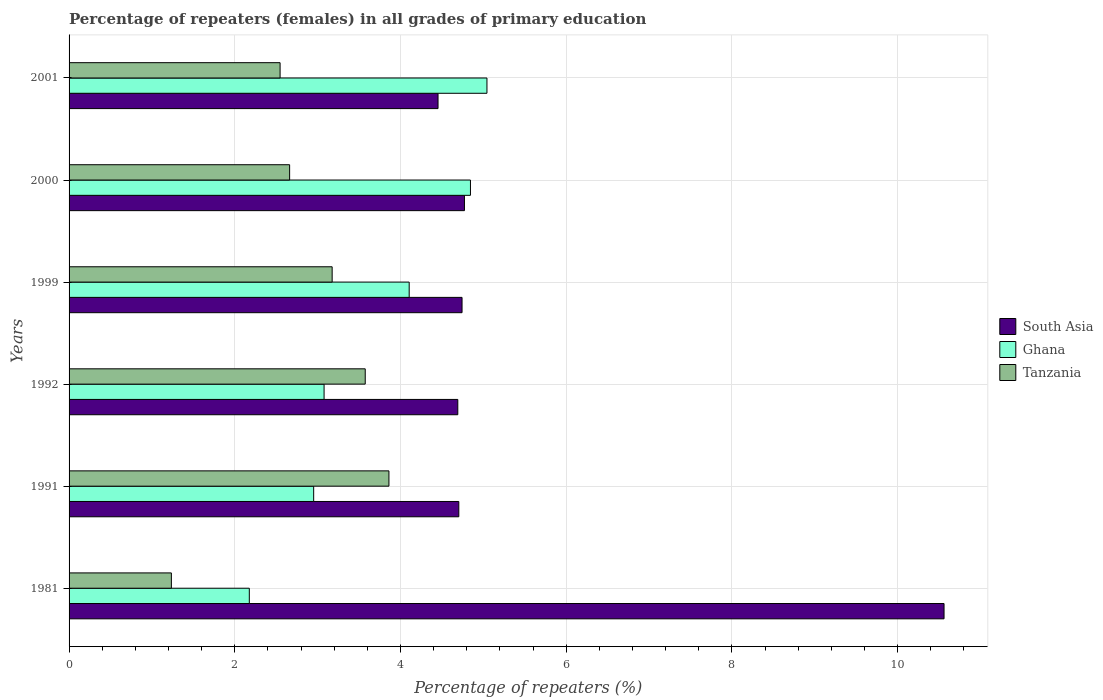Are the number of bars per tick equal to the number of legend labels?
Make the answer very short. Yes. How many bars are there on the 3rd tick from the top?
Your answer should be compact. 3. How many bars are there on the 1st tick from the bottom?
Make the answer very short. 3. What is the label of the 6th group of bars from the top?
Make the answer very short. 1981. In how many cases, is the number of bars for a given year not equal to the number of legend labels?
Offer a terse response. 0. What is the percentage of repeaters (females) in South Asia in 2000?
Give a very brief answer. 4.77. Across all years, what is the maximum percentage of repeaters (females) in Ghana?
Provide a short and direct response. 5.04. Across all years, what is the minimum percentage of repeaters (females) in Tanzania?
Your answer should be compact. 1.23. In which year was the percentage of repeaters (females) in South Asia maximum?
Offer a terse response. 1981. In which year was the percentage of repeaters (females) in South Asia minimum?
Provide a succinct answer. 2001. What is the total percentage of repeaters (females) in Tanzania in the graph?
Make the answer very short. 17.05. What is the difference between the percentage of repeaters (females) in South Asia in 1999 and that in 2001?
Your answer should be very brief. 0.29. What is the difference between the percentage of repeaters (females) in Tanzania in 1991 and the percentage of repeaters (females) in Ghana in 1999?
Offer a terse response. -0.24. What is the average percentage of repeaters (females) in South Asia per year?
Your answer should be very brief. 5.65. In the year 2001, what is the difference between the percentage of repeaters (females) in South Asia and percentage of repeaters (females) in Tanzania?
Offer a very short reply. 1.91. What is the ratio of the percentage of repeaters (females) in Tanzania in 1981 to that in 2000?
Provide a succinct answer. 0.46. Is the percentage of repeaters (females) in Ghana in 2000 less than that in 2001?
Your answer should be very brief. Yes. Is the difference between the percentage of repeaters (females) in South Asia in 2000 and 2001 greater than the difference between the percentage of repeaters (females) in Tanzania in 2000 and 2001?
Your answer should be very brief. Yes. What is the difference between the highest and the second highest percentage of repeaters (females) in South Asia?
Make the answer very short. 5.79. What is the difference between the highest and the lowest percentage of repeaters (females) in South Asia?
Your answer should be compact. 6.11. Is the sum of the percentage of repeaters (females) in Ghana in 1992 and 2001 greater than the maximum percentage of repeaters (females) in South Asia across all years?
Your response must be concise. No. What does the 2nd bar from the bottom in 1991 represents?
Ensure brevity in your answer.  Ghana. Is it the case that in every year, the sum of the percentage of repeaters (females) in South Asia and percentage of repeaters (females) in Ghana is greater than the percentage of repeaters (females) in Tanzania?
Ensure brevity in your answer.  Yes. How many bars are there?
Provide a succinct answer. 18. Are all the bars in the graph horizontal?
Your answer should be very brief. Yes. Does the graph contain any zero values?
Offer a terse response. No. Does the graph contain grids?
Provide a short and direct response. Yes. Where does the legend appear in the graph?
Offer a very short reply. Center right. What is the title of the graph?
Your answer should be very brief. Percentage of repeaters (females) in all grades of primary education. What is the label or title of the X-axis?
Offer a very short reply. Percentage of repeaters (%). What is the label or title of the Y-axis?
Provide a short and direct response. Years. What is the Percentage of repeaters (%) of South Asia in 1981?
Make the answer very short. 10.56. What is the Percentage of repeaters (%) in Ghana in 1981?
Ensure brevity in your answer.  2.18. What is the Percentage of repeaters (%) of Tanzania in 1981?
Your response must be concise. 1.23. What is the Percentage of repeaters (%) of South Asia in 1991?
Give a very brief answer. 4.7. What is the Percentage of repeaters (%) in Ghana in 1991?
Your answer should be very brief. 2.95. What is the Percentage of repeaters (%) of Tanzania in 1991?
Provide a succinct answer. 3.86. What is the Percentage of repeaters (%) in South Asia in 1992?
Make the answer very short. 4.69. What is the Percentage of repeaters (%) in Ghana in 1992?
Keep it short and to the point. 3.08. What is the Percentage of repeaters (%) in Tanzania in 1992?
Offer a terse response. 3.57. What is the Percentage of repeaters (%) of South Asia in 1999?
Your response must be concise. 4.74. What is the Percentage of repeaters (%) of Ghana in 1999?
Your response must be concise. 4.11. What is the Percentage of repeaters (%) of Tanzania in 1999?
Provide a short and direct response. 3.18. What is the Percentage of repeaters (%) in South Asia in 2000?
Give a very brief answer. 4.77. What is the Percentage of repeaters (%) of Ghana in 2000?
Make the answer very short. 4.84. What is the Percentage of repeaters (%) in Tanzania in 2000?
Offer a terse response. 2.66. What is the Percentage of repeaters (%) of South Asia in 2001?
Provide a short and direct response. 4.45. What is the Percentage of repeaters (%) of Ghana in 2001?
Offer a very short reply. 5.04. What is the Percentage of repeaters (%) of Tanzania in 2001?
Your response must be concise. 2.55. Across all years, what is the maximum Percentage of repeaters (%) of South Asia?
Make the answer very short. 10.56. Across all years, what is the maximum Percentage of repeaters (%) in Ghana?
Your answer should be very brief. 5.04. Across all years, what is the maximum Percentage of repeaters (%) of Tanzania?
Keep it short and to the point. 3.86. Across all years, what is the minimum Percentage of repeaters (%) in South Asia?
Keep it short and to the point. 4.45. Across all years, what is the minimum Percentage of repeaters (%) in Ghana?
Your answer should be very brief. 2.18. Across all years, what is the minimum Percentage of repeaters (%) in Tanzania?
Offer a terse response. 1.23. What is the total Percentage of repeaters (%) of South Asia in the graph?
Offer a very short reply. 33.93. What is the total Percentage of repeaters (%) of Ghana in the graph?
Provide a short and direct response. 22.2. What is the total Percentage of repeaters (%) of Tanzania in the graph?
Offer a terse response. 17.05. What is the difference between the Percentage of repeaters (%) in South Asia in 1981 and that in 1991?
Keep it short and to the point. 5.86. What is the difference between the Percentage of repeaters (%) of Ghana in 1981 and that in 1991?
Provide a succinct answer. -0.78. What is the difference between the Percentage of repeaters (%) in Tanzania in 1981 and that in 1991?
Your answer should be compact. -2.63. What is the difference between the Percentage of repeaters (%) of South Asia in 1981 and that in 1992?
Your answer should be compact. 5.87. What is the difference between the Percentage of repeaters (%) of Ghana in 1981 and that in 1992?
Offer a terse response. -0.9. What is the difference between the Percentage of repeaters (%) in Tanzania in 1981 and that in 1992?
Your response must be concise. -2.34. What is the difference between the Percentage of repeaters (%) of South Asia in 1981 and that in 1999?
Offer a very short reply. 5.82. What is the difference between the Percentage of repeaters (%) of Ghana in 1981 and that in 1999?
Your answer should be very brief. -1.93. What is the difference between the Percentage of repeaters (%) in Tanzania in 1981 and that in 1999?
Provide a short and direct response. -1.94. What is the difference between the Percentage of repeaters (%) in South Asia in 1981 and that in 2000?
Provide a succinct answer. 5.79. What is the difference between the Percentage of repeaters (%) of Ghana in 1981 and that in 2000?
Provide a succinct answer. -2.67. What is the difference between the Percentage of repeaters (%) in Tanzania in 1981 and that in 2000?
Offer a terse response. -1.43. What is the difference between the Percentage of repeaters (%) in South Asia in 1981 and that in 2001?
Give a very brief answer. 6.11. What is the difference between the Percentage of repeaters (%) in Ghana in 1981 and that in 2001?
Your response must be concise. -2.87. What is the difference between the Percentage of repeaters (%) in Tanzania in 1981 and that in 2001?
Your answer should be very brief. -1.31. What is the difference between the Percentage of repeaters (%) in South Asia in 1991 and that in 1992?
Your answer should be very brief. 0.01. What is the difference between the Percentage of repeaters (%) in Ghana in 1991 and that in 1992?
Your answer should be very brief. -0.13. What is the difference between the Percentage of repeaters (%) in Tanzania in 1991 and that in 1992?
Ensure brevity in your answer.  0.29. What is the difference between the Percentage of repeaters (%) of South Asia in 1991 and that in 1999?
Ensure brevity in your answer.  -0.04. What is the difference between the Percentage of repeaters (%) of Ghana in 1991 and that in 1999?
Your answer should be compact. -1.15. What is the difference between the Percentage of repeaters (%) in Tanzania in 1991 and that in 1999?
Offer a very short reply. 0.69. What is the difference between the Percentage of repeaters (%) of South Asia in 1991 and that in 2000?
Offer a terse response. -0.07. What is the difference between the Percentage of repeaters (%) in Ghana in 1991 and that in 2000?
Offer a very short reply. -1.89. What is the difference between the Percentage of repeaters (%) in Tanzania in 1991 and that in 2000?
Your answer should be compact. 1.2. What is the difference between the Percentage of repeaters (%) in South Asia in 1991 and that in 2001?
Offer a very short reply. 0.25. What is the difference between the Percentage of repeaters (%) of Ghana in 1991 and that in 2001?
Provide a succinct answer. -2.09. What is the difference between the Percentage of repeaters (%) of Tanzania in 1991 and that in 2001?
Provide a succinct answer. 1.31. What is the difference between the Percentage of repeaters (%) in South Asia in 1992 and that in 1999?
Ensure brevity in your answer.  -0.05. What is the difference between the Percentage of repeaters (%) in Ghana in 1992 and that in 1999?
Your answer should be compact. -1.03. What is the difference between the Percentage of repeaters (%) of Tanzania in 1992 and that in 1999?
Make the answer very short. 0.4. What is the difference between the Percentage of repeaters (%) of South Asia in 1992 and that in 2000?
Make the answer very short. -0.08. What is the difference between the Percentage of repeaters (%) of Ghana in 1992 and that in 2000?
Provide a succinct answer. -1.77. What is the difference between the Percentage of repeaters (%) in Tanzania in 1992 and that in 2000?
Provide a succinct answer. 0.91. What is the difference between the Percentage of repeaters (%) of South Asia in 1992 and that in 2001?
Offer a very short reply. 0.24. What is the difference between the Percentage of repeaters (%) in Ghana in 1992 and that in 2001?
Offer a terse response. -1.97. What is the difference between the Percentage of repeaters (%) of Tanzania in 1992 and that in 2001?
Your answer should be compact. 1.03. What is the difference between the Percentage of repeaters (%) of South Asia in 1999 and that in 2000?
Offer a very short reply. -0.03. What is the difference between the Percentage of repeaters (%) in Ghana in 1999 and that in 2000?
Make the answer very short. -0.74. What is the difference between the Percentage of repeaters (%) in Tanzania in 1999 and that in 2000?
Ensure brevity in your answer.  0.51. What is the difference between the Percentage of repeaters (%) in South Asia in 1999 and that in 2001?
Provide a short and direct response. 0.29. What is the difference between the Percentage of repeaters (%) of Ghana in 1999 and that in 2001?
Make the answer very short. -0.94. What is the difference between the Percentage of repeaters (%) of Tanzania in 1999 and that in 2001?
Give a very brief answer. 0.63. What is the difference between the Percentage of repeaters (%) in South Asia in 2000 and that in 2001?
Make the answer very short. 0.32. What is the difference between the Percentage of repeaters (%) of Ghana in 2000 and that in 2001?
Offer a terse response. -0.2. What is the difference between the Percentage of repeaters (%) in Tanzania in 2000 and that in 2001?
Offer a terse response. 0.12. What is the difference between the Percentage of repeaters (%) of South Asia in 1981 and the Percentage of repeaters (%) of Ghana in 1991?
Provide a short and direct response. 7.61. What is the difference between the Percentage of repeaters (%) in Ghana in 1981 and the Percentage of repeaters (%) in Tanzania in 1991?
Give a very brief answer. -1.69. What is the difference between the Percentage of repeaters (%) in South Asia in 1981 and the Percentage of repeaters (%) in Ghana in 1992?
Your answer should be very brief. 7.48. What is the difference between the Percentage of repeaters (%) of South Asia in 1981 and the Percentage of repeaters (%) of Tanzania in 1992?
Offer a terse response. 6.99. What is the difference between the Percentage of repeaters (%) in Ghana in 1981 and the Percentage of repeaters (%) in Tanzania in 1992?
Your response must be concise. -1.4. What is the difference between the Percentage of repeaters (%) in South Asia in 1981 and the Percentage of repeaters (%) in Ghana in 1999?
Ensure brevity in your answer.  6.46. What is the difference between the Percentage of repeaters (%) of South Asia in 1981 and the Percentage of repeaters (%) of Tanzania in 1999?
Ensure brevity in your answer.  7.39. What is the difference between the Percentage of repeaters (%) in Ghana in 1981 and the Percentage of repeaters (%) in Tanzania in 1999?
Provide a succinct answer. -1. What is the difference between the Percentage of repeaters (%) of South Asia in 1981 and the Percentage of repeaters (%) of Ghana in 2000?
Ensure brevity in your answer.  5.72. What is the difference between the Percentage of repeaters (%) of South Asia in 1981 and the Percentage of repeaters (%) of Tanzania in 2000?
Your answer should be very brief. 7.9. What is the difference between the Percentage of repeaters (%) of Ghana in 1981 and the Percentage of repeaters (%) of Tanzania in 2000?
Provide a short and direct response. -0.49. What is the difference between the Percentage of repeaters (%) in South Asia in 1981 and the Percentage of repeaters (%) in Ghana in 2001?
Ensure brevity in your answer.  5.52. What is the difference between the Percentage of repeaters (%) in South Asia in 1981 and the Percentage of repeaters (%) in Tanzania in 2001?
Your response must be concise. 8.01. What is the difference between the Percentage of repeaters (%) in Ghana in 1981 and the Percentage of repeaters (%) in Tanzania in 2001?
Provide a short and direct response. -0.37. What is the difference between the Percentage of repeaters (%) in South Asia in 1991 and the Percentage of repeaters (%) in Ghana in 1992?
Offer a terse response. 1.63. What is the difference between the Percentage of repeaters (%) in South Asia in 1991 and the Percentage of repeaters (%) in Tanzania in 1992?
Provide a succinct answer. 1.13. What is the difference between the Percentage of repeaters (%) of Ghana in 1991 and the Percentage of repeaters (%) of Tanzania in 1992?
Offer a terse response. -0.62. What is the difference between the Percentage of repeaters (%) of South Asia in 1991 and the Percentage of repeaters (%) of Ghana in 1999?
Keep it short and to the point. 0.6. What is the difference between the Percentage of repeaters (%) of South Asia in 1991 and the Percentage of repeaters (%) of Tanzania in 1999?
Your answer should be compact. 1.53. What is the difference between the Percentage of repeaters (%) of Ghana in 1991 and the Percentage of repeaters (%) of Tanzania in 1999?
Provide a short and direct response. -0.22. What is the difference between the Percentage of repeaters (%) in South Asia in 1991 and the Percentage of repeaters (%) in Ghana in 2000?
Ensure brevity in your answer.  -0.14. What is the difference between the Percentage of repeaters (%) in South Asia in 1991 and the Percentage of repeaters (%) in Tanzania in 2000?
Provide a short and direct response. 2.04. What is the difference between the Percentage of repeaters (%) in Ghana in 1991 and the Percentage of repeaters (%) in Tanzania in 2000?
Offer a terse response. 0.29. What is the difference between the Percentage of repeaters (%) in South Asia in 1991 and the Percentage of repeaters (%) in Ghana in 2001?
Your response must be concise. -0.34. What is the difference between the Percentage of repeaters (%) of South Asia in 1991 and the Percentage of repeaters (%) of Tanzania in 2001?
Your answer should be very brief. 2.16. What is the difference between the Percentage of repeaters (%) in Ghana in 1991 and the Percentage of repeaters (%) in Tanzania in 2001?
Provide a succinct answer. 0.41. What is the difference between the Percentage of repeaters (%) of South Asia in 1992 and the Percentage of repeaters (%) of Ghana in 1999?
Give a very brief answer. 0.59. What is the difference between the Percentage of repeaters (%) of South Asia in 1992 and the Percentage of repeaters (%) of Tanzania in 1999?
Ensure brevity in your answer.  1.52. What is the difference between the Percentage of repeaters (%) in Ghana in 1992 and the Percentage of repeaters (%) in Tanzania in 1999?
Give a very brief answer. -0.1. What is the difference between the Percentage of repeaters (%) in South Asia in 1992 and the Percentage of repeaters (%) in Ghana in 2000?
Ensure brevity in your answer.  -0.15. What is the difference between the Percentage of repeaters (%) in South Asia in 1992 and the Percentage of repeaters (%) in Tanzania in 2000?
Provide a short and direct response. 2.03. What is the difference between the Percentage of repeaters (%) of Ghana in 1992 and the Percentage of repeaters (%) of Tanzania in 2000?
Offer a very short reply. 0.42. What is the difference between the Percentage of repeaters (%) of South Asia in 1992 and the Percentage of repeaters (%) of Ghana in 2001?
Your answer should be very brief. -0.35. What is the difference between the Percentage of repeaters (%) in South Asia in 1992 and the Percentage of repeaters (%) in Tanzania in 2001?
Offer a very short reply. 2.14. What is the difference between the Percentage of repeaters (%) of Ghana in 1992 and the Percentage of repeaters (%) of Tanzania in 2001?
Keep it short and to the point. 0.53. What is the difference between the Percentage of repeaters (%) in South Asia in 1999 and the Percentage of repeaters (%) in Ghana in 2000?
Your answer should be very brief. -0.1. What is the difference between the Percentage of repeaters (%) in South Asia in 1999 and the Percentage of repeaters (%) in Tanzania in 2000?
Make the answer very short. 2.08. What is the difference between the Percentage of repeaters (%) in Ghana in 1999 and the Percentage of repeaters (%) in Tanzania in 2000?
Ensure brevity in your answer.  1.44. What is the difference between the Percentage of repeaters (%) of South Asia in 1999 and the Percentage of repeaters (%) of Ghana in 2001?
Keep it short and to the point. -0.3. What is the difference between the Percentage of repeaters (%) in South Asia in 1999 and the Percentage of repeaters (%) in Tanzania in 2001?
Your answer should be compact. 2.2. What is the difference between the Percentage of repeaters (%) in Ghana in 1999 and the Percentage of repeaters (%) in Tanzania in 2001?
Your response must be concise. 1.56. What is the difference between the Percentage of repeaters (%) of South Asia in 2000 and the Percentage of repeaters (%) of Ghana in 2001?
Keep it short and to the point. -0.27. What is the difference between the Percentage of repeaters (%) of South Asia in 2000 and the Percentage of repeaters (%) of Tanzania in 2001?
Ensure brevity in your answer.  2.23. What is the difference between the Percentage of repeaters (%) in Ghana in 2000 and the Percentage of repeaters (%) in Tanzania in 2001?
Provide a short and direct response. 2.3. What is the average Percentage of repeaters (%) in South Asia per year?
Ensure brevity in your answer.  5.65. What is the average Percentage of repeaters (%) in Ghana per year?
Make the answer very short. 3.7. What is the average Percentage of repeaters (%) in Tanzania per year?
Keep it short and to the point. 2.84. In the year 1981, what is the difference between the Percentage of repeaters (%) in South Asia and Percentage of repeaters (%) in Ghana?
Make the answer very short. 8.39. In the year 1981, what is the difference between the Percentage of repeaters (%) of South Asia and Percentage of repeaters (%) of Tanzania?
Provide a short and direct response. 9.33. In the year 1981, what is the difference between the Percentage of repeaters (%) of Ghana and Percentage of repeaters (%) of Tanzania?
Ensure brevity in your answer.  0.94. In the year 1991, what is the difference between the Percentage of repeaters (%) of South Asia and Percentage of repeaters (%) of Ghana?
Give a very brief answer. 1.75. In the year 1991, what is the difference between the Percentage of repeaters (%) of South Asia and Percentage of repeaters (%) of Tanzania?
Provide a short and direct response. 0.84. In the year 1991, what is the difference between the Percentage of repeaters (%) of Ghana and Percentage of repeaters (%) of Tanzania?
Your answer should be very brief. -0.91. In the year 1992, what is the difference between the Percentage of repeaters (%) in South Asia and Percentage of repeaters (%) in Ghana?
Keep it short and to the point. 1.61. In the year 1992, what is the difference between the Percentage of repeaters (%) of South Asia and Percentage of repeaters (%) of Tanzania?
Provide a succinct answer. 1.12. In the year 1992, what is the difference between the Percentage of repeaters (%) of Ghana and Percentage of repeaters (%) of Tanzania?
Your response must be concise. -0.5. In the year 1999, what is the difference between the Percentage of repeaters (%) in South Asia and Percentage of repeaters (%) in Ghana?
Give a very brief answer. 0.64. In the year 1999, what is the difference between the Percentage of repeaters (%) in South Asia and Percentage of repeaters (%) in Tanzania?
Offer a very short reply. 1.57. In the year 1999, what is the difference between the Percentage of repeaters (%) of Ghana and Percentage of repeaters (%) of Tanzania?
Your response must be concise. 0.93. In the year 2000, what is the difference between the Percentage of repeaters (%) in South Asia and Percentage of repeaters (%) in Ghana?
Your answer should be compact. -0.07. In the year 2000, what is the difference between the Percentage of repeaters (%) of South Asia and Percentage of repeaters (%) of Tanzania?
Your response must be concise. 2.11. In the year 2000, what is the difference between the Percentage of repeaters (%) in Ghana and Percentage of repeaters (%) in Tanzania?
Offer a terse response. 2.18. In the year 2001, what is the difference between the Percentage of repeaters (%) in South Asia and Percentage of repeaters (%) in Ghana?
Make the answer very short. -0.59. In the year 2001, what is the difference between the Percentage of repeaters (%) of South Asia and Percentage of repeaters (%) of Tanzania?
Provide a succinct answer. 1.91. In the year 2001, what is the difference between the Percentage of repeaters (%) in Ghana and Percentage of repeaters (%) in Tanzania?
Your answer should be compact. 2.5. What is the ratio of the Percentage of repeaters (%) of South Asia in 1981 to that in 1991?
Provide a succinct answer. 2.25. What is the ratio of the Percentage of repeaters (%) of Ghana in 1981 to that in 1991?
Your response must be concise. 0.74. What is the ratio of the Percentage of repeaters (%) of Tanzania in 1981 to that in 1991?
Offer a very short reply. 0.32. What is the ratio of the Percentage of repeaters (%) of South Asia in 1981 to that in 1992?
Make the answer very short. 2.25. What is the ratio of the Percentage of repeaters (%) in Ghana in 1981 to that in 1992?
Your answer should be very brief. 0.71. What is the ratio of the Percentage of repeaters (%) in Tanzania in 1981 to that in 1992?
Provide a succinct answer. 0.35. What is the ratio of the Percentage of repeaters (%) in South Asia in 1981 to that in 1999?
Your answer should be very brief. 2.23. What is the ratio of the Percentage of repeaters (%) of Ghana in 1981 to that in 1999?
Your answer should be very brief. 0.53. What is the ratio of the Percentage of repeaters (%) in Tanzania in 1981 to that in 1999?
Provide a succinct answer. 0.39. What is the ratio of the Percentage of repeaters (%) of South Asia in 1981 to that in 2000?
Provide a succinct answer. 2.21. What is the ratio of the Percentage of repeaters (%) in Ghana in 1981 to that in 2000?
Your answer should be very brief. 0.45. What is the ratio of the Percentage of repeaters (%) in Tanzania in 1981 to that in 2000?
Provide a succinct answer. 0.46. What is the ratio of the Percentage of repeaters (%) in South Asia in 1981 to that in 2001?
Give a very brief answer. 2.37. What is the ratio of the Percentage of repeaters (%) of Ghana in 1981 to that in 2001?
Your response must be concise. 0.43. What is the ratio of the Percentage of repeaters (%) in Tanzania in 1981 to that in 2001?
Offer a very short reply. 0.48. What is the ratio of the Percentage of repeaters (%) of Ghana in 1991 to that in 1992?
Offer a terse response. 0.96. What is the ratio of the Percentage of repeaters (%) of Tanzania in 1991 to that in 1992?
Your answer should be very brief. 1.08. What is the ratio of the Percentage of repeaters (%) of Ghana in 1991 to that in 1999?
Make the answer very short. 0.72. What is the ratio of the Percentage of repeaters (%) in Tanzania in 1991 to that in 1999?
Make the answer very short. 1.22. What is the ratio of the Percentage of repeaters (%) of South Asia in 1991 to that in 2000?
Offer a terse response. 0.99. What is the ratio of the Percentage of repeaters (%) of Ghana in 1991 to that in 2000?
Keep it short and to the point. 0.61. What is the ratio of the Percentage of repeaters (%) of Tanzania in 1991 to that in 2000?
Give a very brief answer. 1.45. What is the ratio of the Percentage of repeaters (%) in South Asia in 1991 to that in 2001?
Your answer should be compact. 1.06. What is the ratio of the Percentage of repeaters (%) of Ghana in 1991 to that in 2001?
Offer a terse response. 0.59. What is the ratio of the Percentage of repeaters (%) of Tanzania in 1991 to that in 2001?
Offer a terse response. 1.52. What is the ratio of the Percentage of repeaters (%) in South Asia in 1992 to that in 1999?
Give a very brief answer. 0.99. What is the ratio of the Percentage of repeaters (%) of Ghana in 1992 to that in 1999?
Your response must be concise. 0.75. What is the ratio of the Percentage of repeaters (%) of Tanzania in 1992 to that in 1999?
Make the answer very short. 1.13. What is the ratio of the Percentage of repeaters (%) in South Asia in 1992 to that in 2000?
Offer a terse response. 0.98. What is the ratio of the Percentage of repeaters (%) in Ghana in 1992 to that in 2000?
Offer a very short reply. 0.64. What is the ratio of the Percentage of repeaters (%) of Tanzania in 1992 to that in 2000?
Make the answer very short. 1.34. What is the ratio of the Percentage of repeaters (%) in South Asia in 1992 to that in 2001?
Offer a very short reply. 1.05. What is the ratio of the Percentage of repeaters (%) of Ghana in 1992 to that in 2001?
Your response must be concise. 0.61. What is the ratio of the Percentage of repeaters (%) of Tanzania in 1992 to that in 2001?
Your answer should be compact. 1.4. What is the ratio of the Percentage of repeaters (%) in Ghana in 1999 to that in 2000?
Provide a short and direct response. 0.85. What is the ratio of the Percentage of repeaters (%) in Tanzania in 1999 to that in 2000?
Make the answer very short. 1.19. What is the ratio of the Percentage of repeaters (%) in South Asia in 1999 to that in 2001?
Keep it short and to the point. 1.07. What is the ratio of the Percentage of repeaters (%) of Ghana in 1999 to that in 2001?
Ensure brevity in your answer.  0.81. What is the ratio of the Percentage of repeaters (%) in Tanzania in 1999 to that in 2001?
Ensure brevity in your answer.  1.25. What is the ratio of the Percentage of repeaters (%) in South Asia in 2000 to that in 2001?
Your response must be concise. 1.07. What is the ratio of the Percentage of repeaters (%) in Ghana in 2000 to that in 2001?
Provide a succinct answer. 0.96. What is the ratio of the Percentage of repeaters (%) in Tanzania in 2000 to that in 2001?
Keep it short and to the point. 1.05. What is the difference between the highest and the second highest Percentage of repeaters (%) in South Asia?
Keep it short and to the point. 5.79. What is the difference between the highest and the second highest Percentage of repeaters (%) in Ghana?
Ensure brevity in your answer.  0.2. What is the difference between the highest and the second highest Percentage of repeaters (%) of Tanzania?
Your answer should be very brief. 0.29. What is the difference between the highest and the lowest Percentage of repeaters (%) in South Asia?
Provide a short and direct response. 6.11. What is the difference between the highest and the lowest Percentage of repeaters (%) of Ghana?
Your response must be concise. 2.87. What is the difference between the highest and the lowest Percentage of repeaters (%) in Tanzania?
Give a very brief answer. 2.63. 